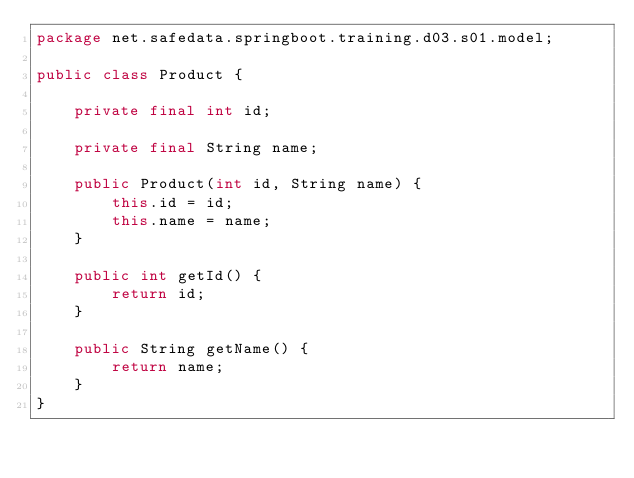<code> <loc_0><loc_0><loc_500><loc_500><_Java_>package net.safedata.springboot.training.d03.s01.model;

public class Product {

    private final int id;

    private final String name;

    public Product(int id, String name) {
        this.id = id;
        this.name = name;
    }

    public int getId() {
        return id;
    }

    public String getName() {
        return name;
    }
}
</code> 